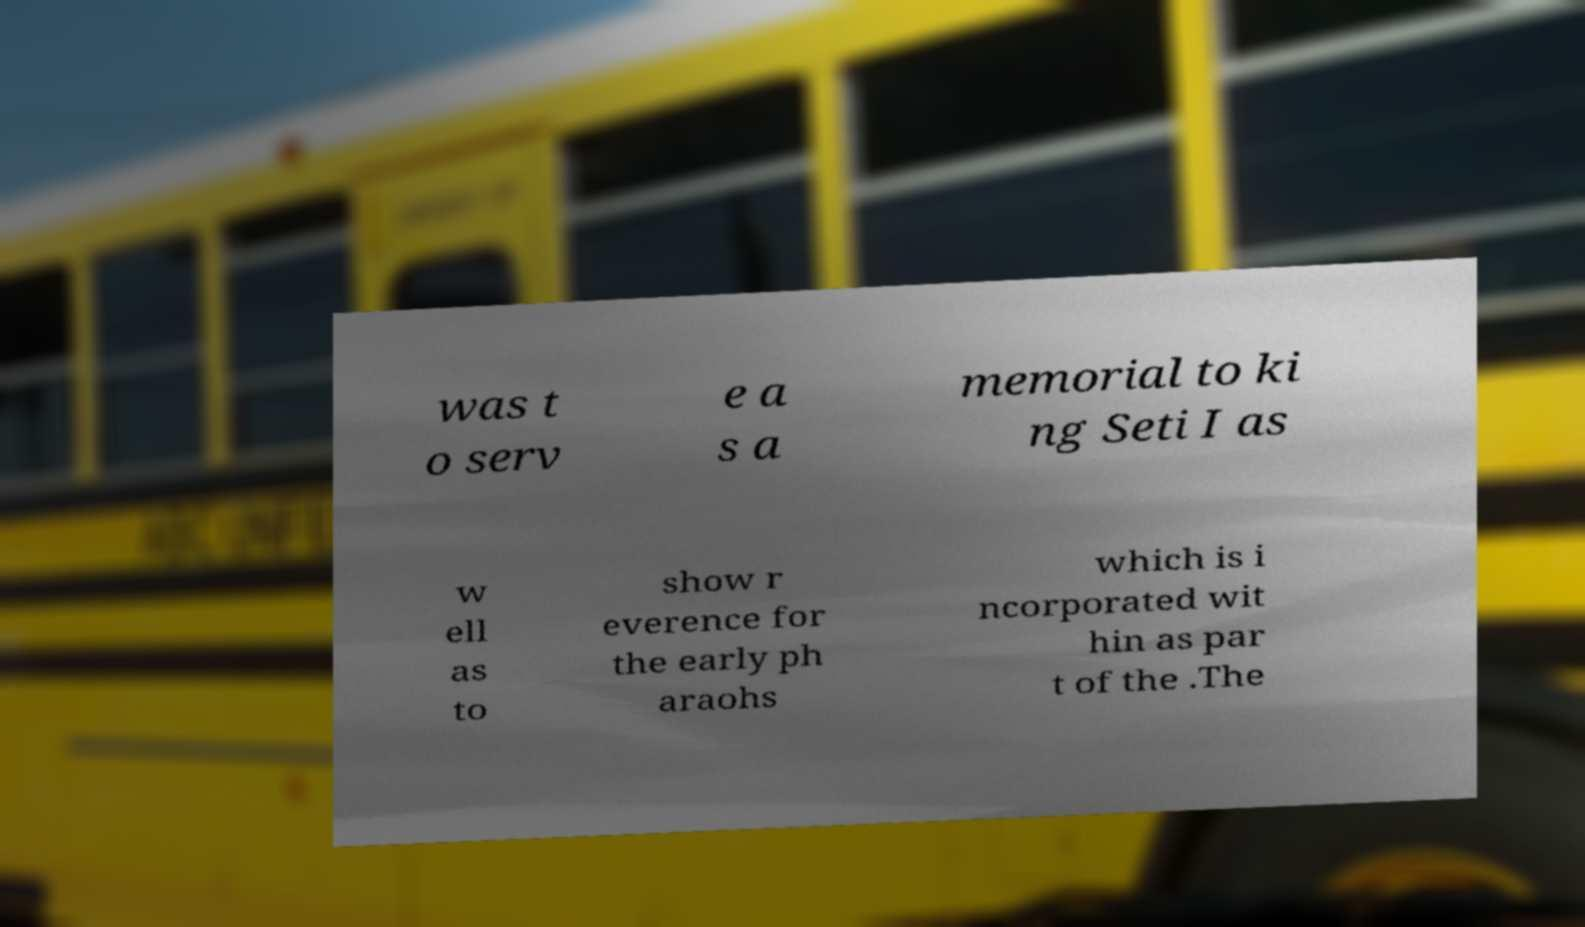Could you assist in decoding the text presented in this image and type it out clearly? was t o serv e a s a memorial to ki ng Seti I as w ell as to show r everence for the early ph araohs which is i ncorporated wit hin as par t of the .The 